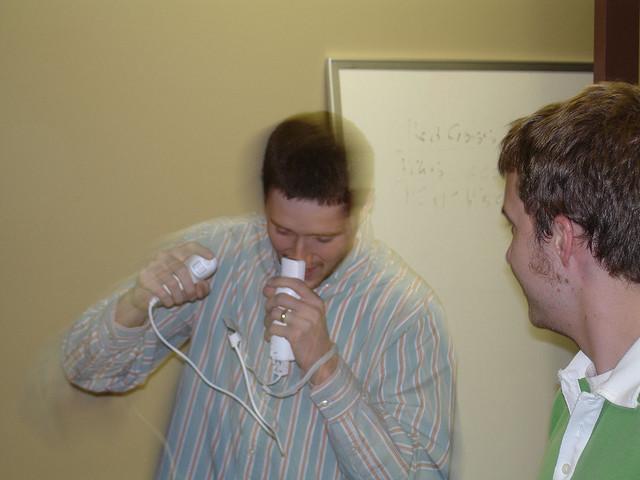What game system is this?
Short answer required. Wii. Is the man wearing a ring?
Quick response, please. Yes. Where are they playing video games?
Quick response, please. Yes. 